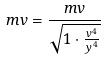<formula> <loc_0><loc_0><loc_500><loc_500>m v = \frac { m v } { \sqrt { 1 \cdot \frac { v ^ { 4 } } { y ^ { 4 } } } }</formula> 